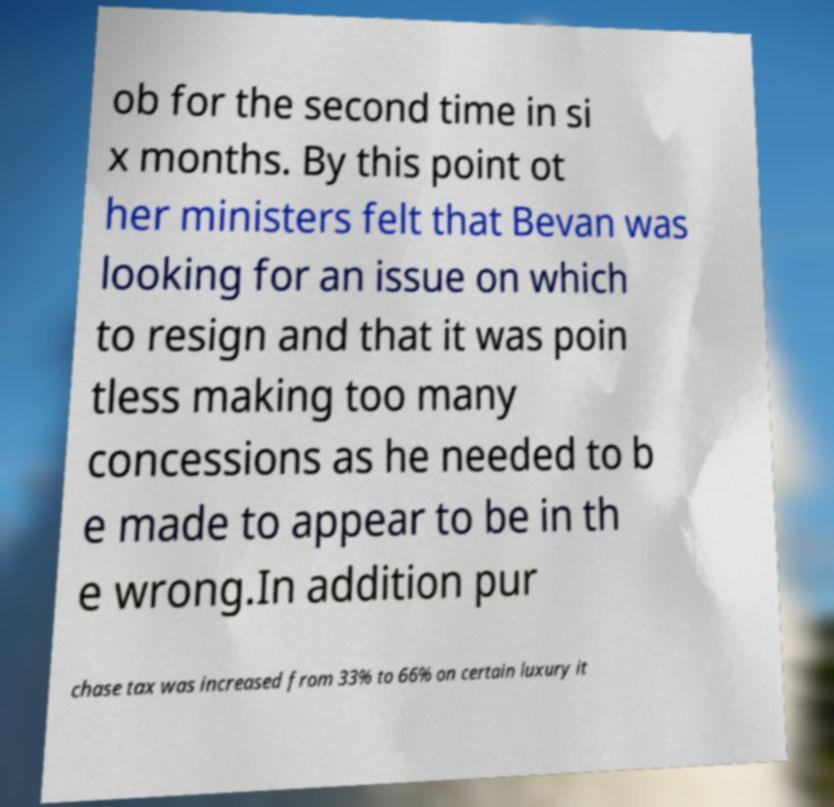Could you assist in decoding the text presented in this image and type it out clearly? ob for the second time in si x months. By this point ot her ministers felt that Bevan was looking for an issue on which to resign and that it was poin tless making too many concessions as he needed to b e made to appear to be in th e wrong.In addition pur chase tax was increased from 33% to 66% on certain luxury it 